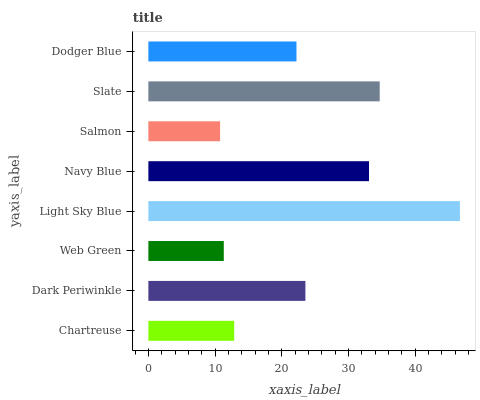Is Salmon the minimum?
Answer yes or no. Yes. Is Light Sky Blue the maximum?
Answer yes or no. Yes. Is Dark Periwinkle the minimum?
Answer yes or no. No. Is Dark Periwinkle the maximum?
Answer yes or no. No. Is Dark Periwinkle greater than Chartreuse?
Answer yes or no. Yes. Is Chartreuse less than Dark Periwinkle?
Answer yes or no. Yes. Is Chartreuse greater than Dark Periwinkle?
Answer yes or no. No. Is Dark Periwinkle less than Chartreuse?
Answer yes or no. No. Is Dark Periwinkle the high median?
Answer yes or no. Yes. Is Dodger Blue the low median?
Answer yes or no. Yes. Is Web Green the high median?
Answer yes or no. No. Is Salmon the low median?
Answer yes or no. No. 